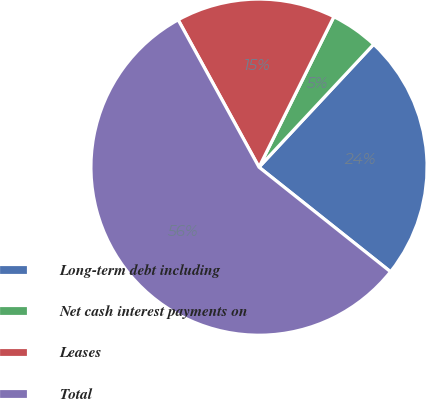Convert chart. <chart><loc_0><loc_0><loc_500><loc_500><pie_chart><fcel>Long-term debt including<fcel>Net cash interest payments on<fcel>Leases<fcel>Total<nl><fcel>23.74%<fcel>4.6%<fcel>15.34%<fcel>56.32%<nl></chart> 